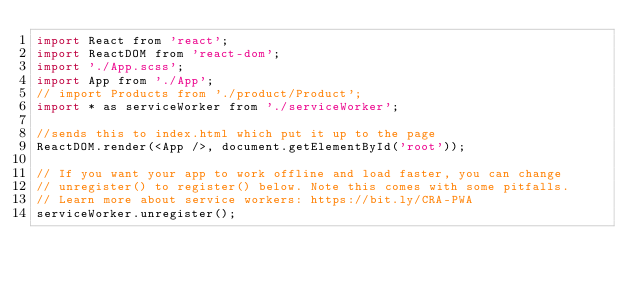<code> <loc_0><loc_0><loc_500><loc_500><_JavaScript_>import React from 'react';
import ReactDOM from 'react-dom';
import './App.scss';
import App from './App';
// import Products from './product/Product';
import * as serviceWorker from './serviceWorker';

//sends this to index.html which put it up to the page
ReactDOM.render(<App />, document.getElementById('root'));

// If you want your app to work offline and load faster, you can change
// unregister() to register() below. Note this comes with some pitfalls.
// Learn more about service workers: https://bit.ly/CRA-PWA
serviceWorker.unregister();
</code> 